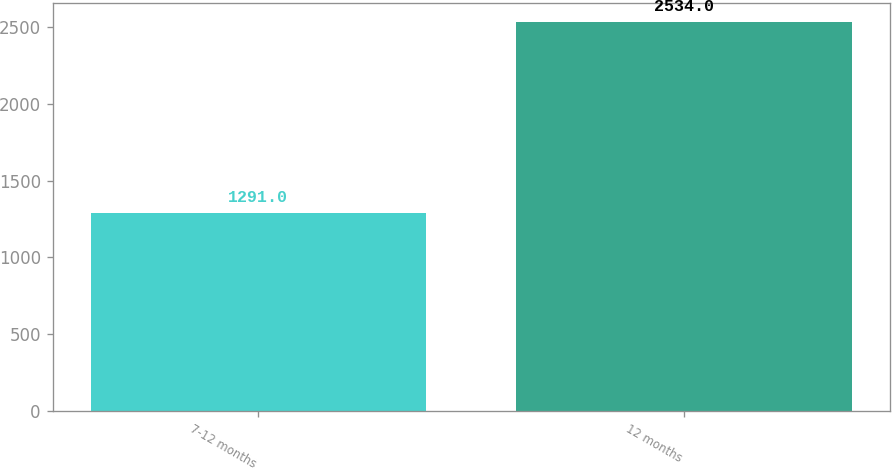Convert chart to OTSL. <chart><loc_0><loc_0><loc_500><loc_500><bar_chart><fcel>7-12 months<fcel>12 months<nl><fcel>1291<fcel>2534<nl></chart> 